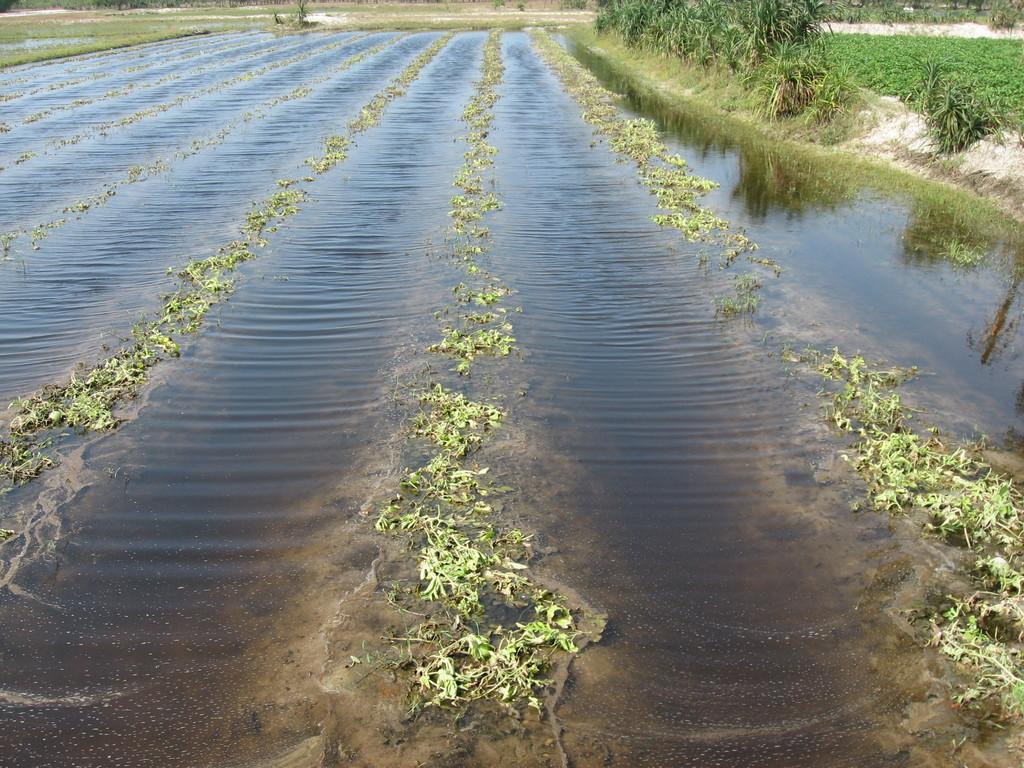In one or two sentences, can you explain what this image depicts? In this image, we can see field with water and in the background, there are plants. 